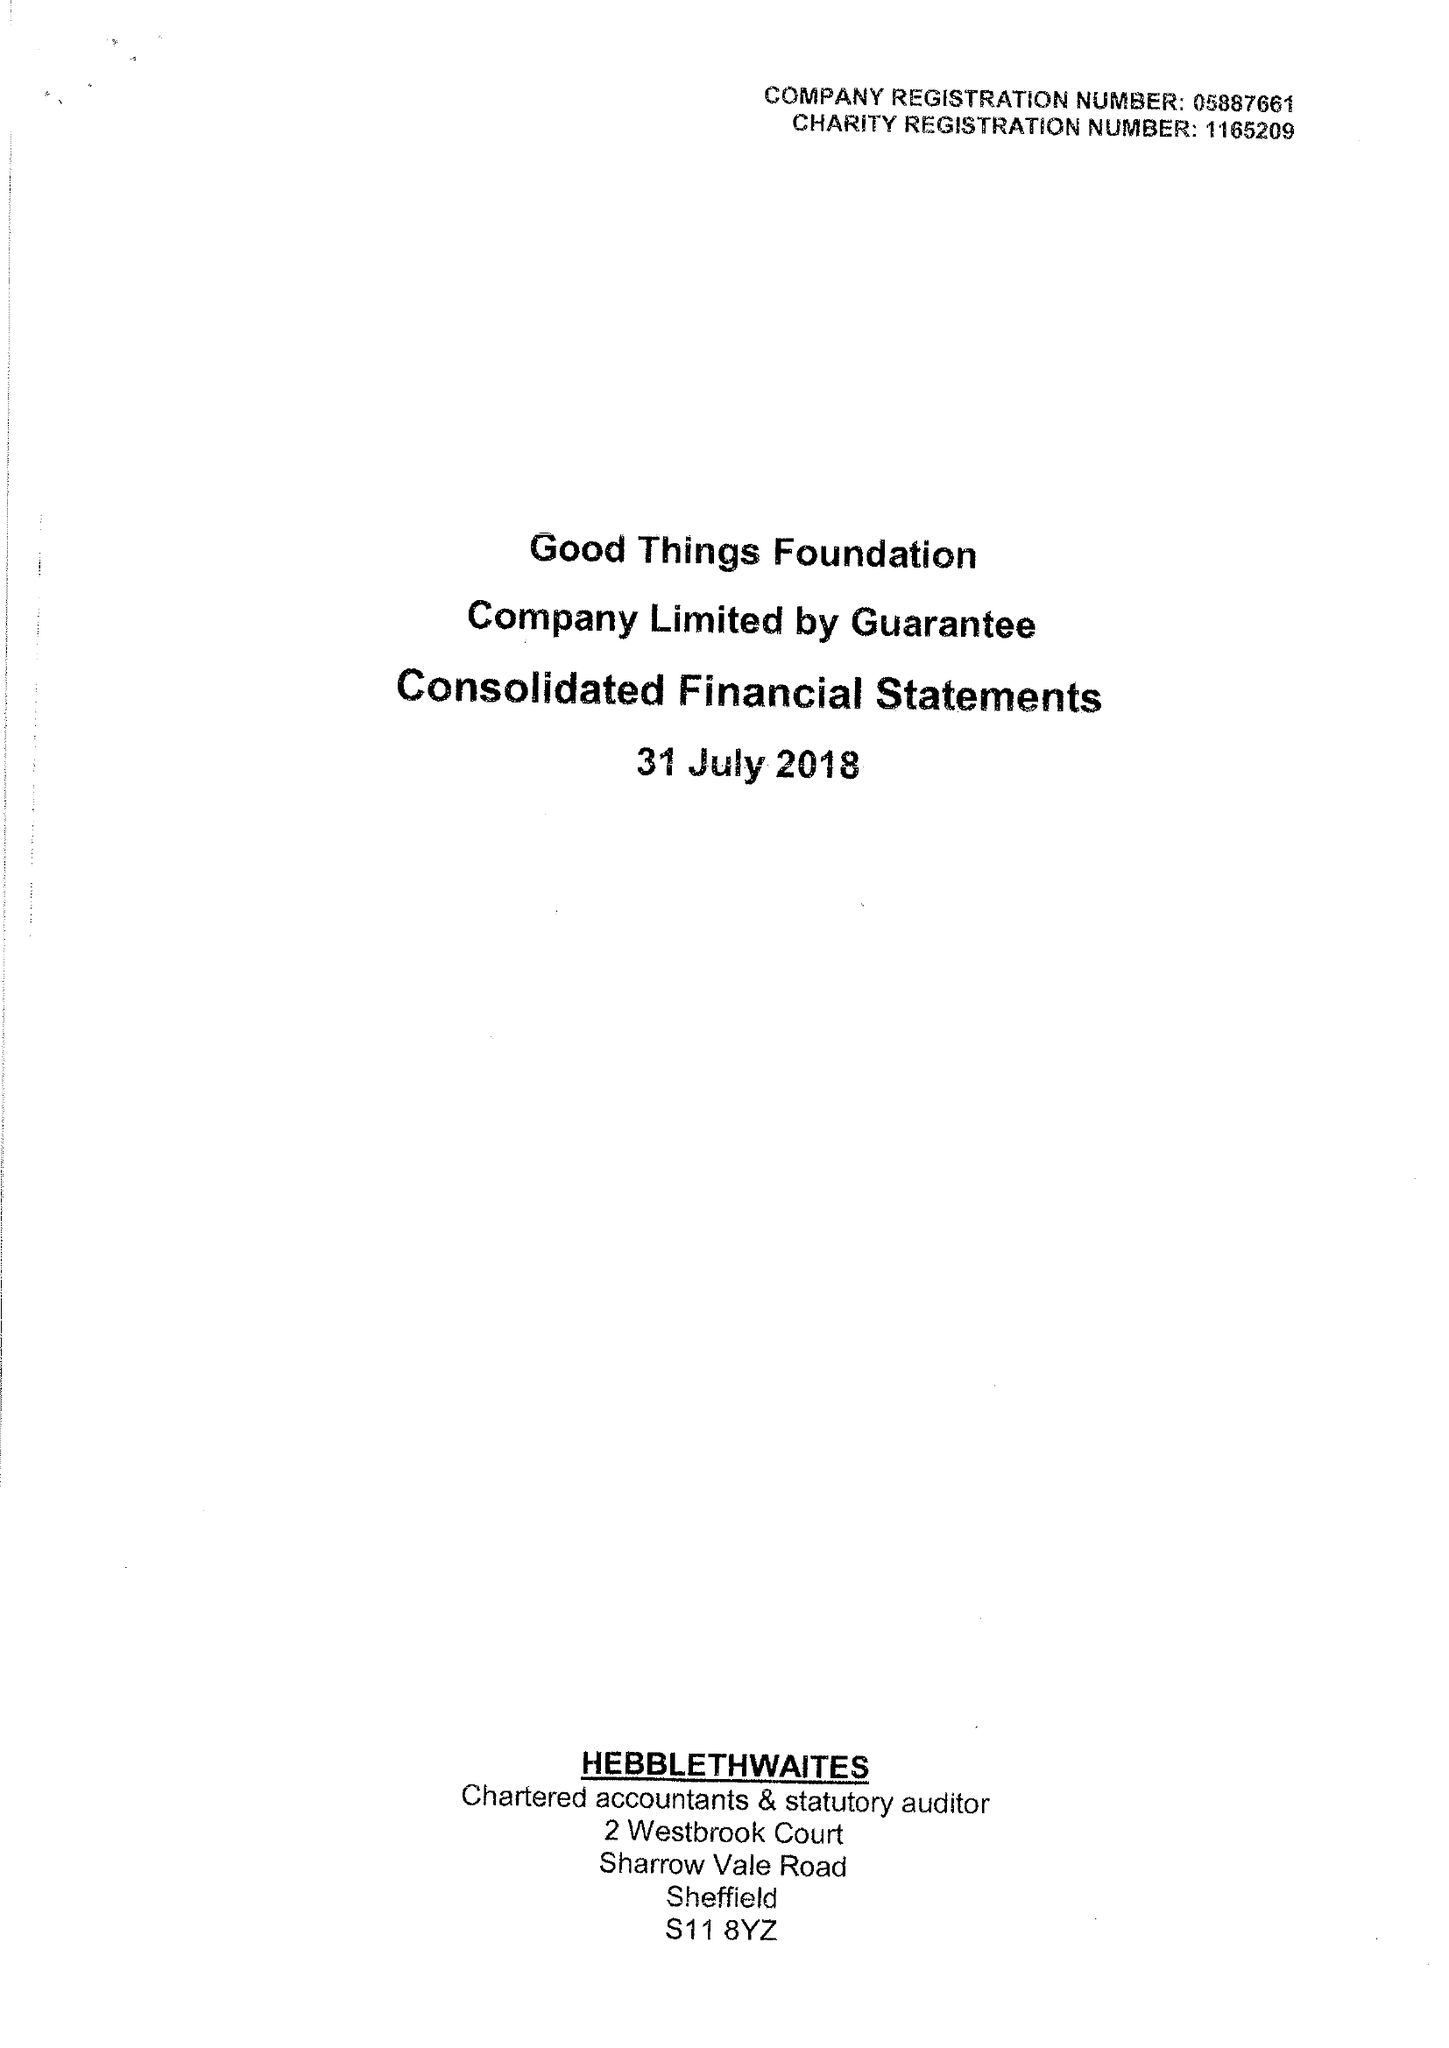What is the value for the address__street_line?
Answer the question using a single word or phrase. 1 EAST PARADE 